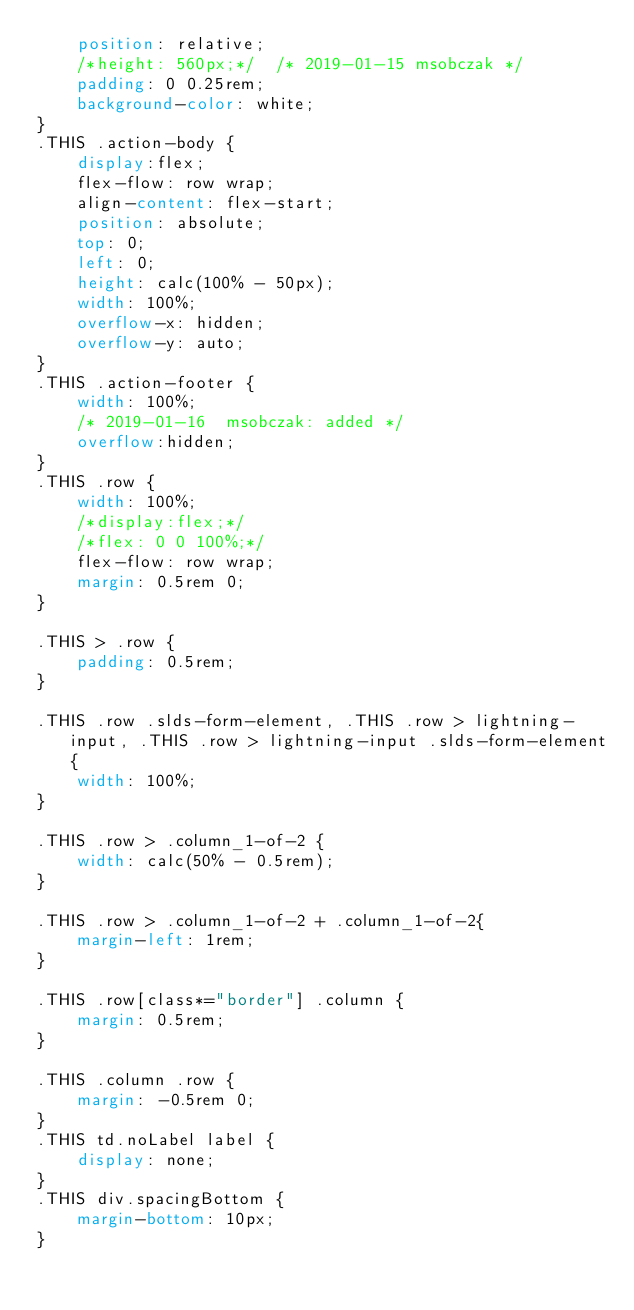<code> <loc_0><loc_0><loc_500><loc_500><_CSS_>    position: relative;
    /*height: 560px;*/  /* 2019-01-15 msobczak */
    padding: 0 0.25rem;
    background-color: white;
}
.THIS .action-body {
    display:flex;
	flex-flow: row wrap;
    align-content: flex-start;
    position: absolute;
    top: 0;
    left: 0;
    height: calc(100% - 50px);
    width: 100%;
    overflow-x: hidden;
    overflow-y: auto;
}
.THIS .action-footer {
    width: 100%;
    /* 2019-01-16  msobczak: added */
    overflow:hidden;
}
.THIS .row {
    width: 100%;
    /*display:flex;*/
    /*flex: 0 0 100%;*/
    flex-flow: row wrap;
    margin: 0.5rem 0;
}

.THIS > .row {
    padding: 0.5rem;
}

.THIS .row .slds-form-element, .THIS .row > lightning-input, .THIS .row > lightning-input .slds-form-element{
    width: 100%;
}

.THIS .row > .column_1-of-2 {
    width: calc(50% - 0.5rem);
}

.THIS .row > .column_1-of-2 + .column_1-of-2{
    margin-left: 1rem;
}

.THIS .row[class*="border"] .column {
    margin: 0.5rem;
}

.THIS .column .row {
    margin: -0.5rem 0;
}
.THIS td.noLabel label {
    display: none;
}
.THIS div.spacingBottom {
    margin-bottom: 10px;
}</code> 